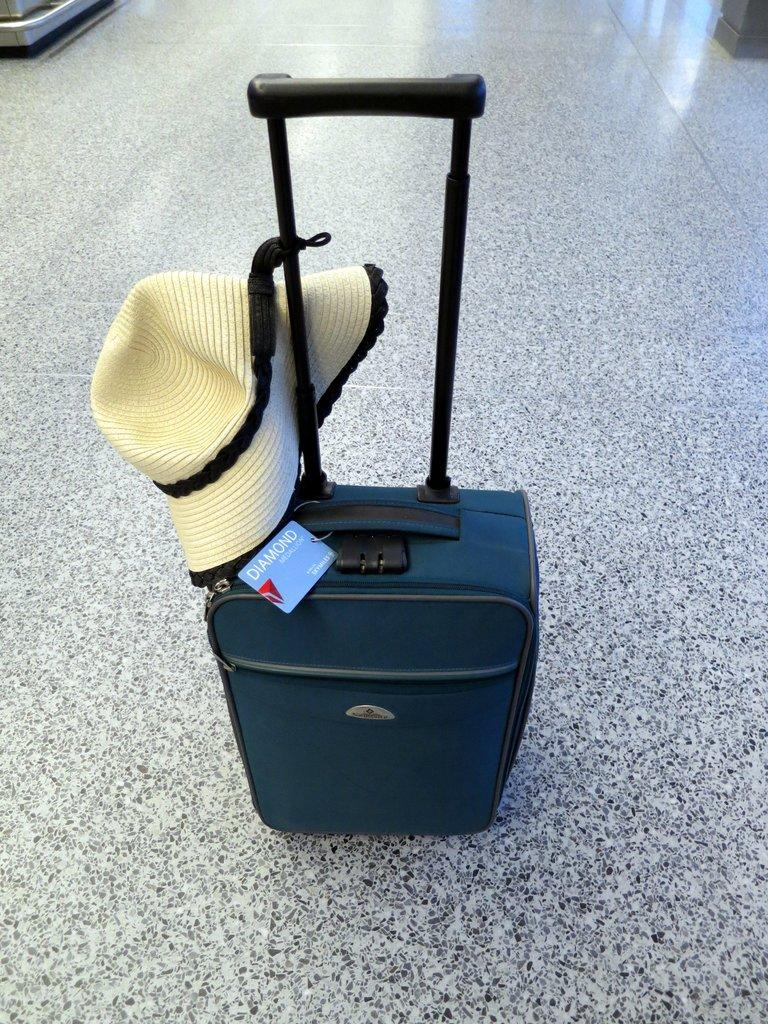What object is present on the floor in the image? There is a bag in the image. What feature is attached to the bag? The bag has a cap attached to it. Where are the bag and cap located in the image? The bag and cap are placed on the floor. What type of health benefits can be gained from the bag in the image? The image does not provide any information about health benefits related to the bag. 